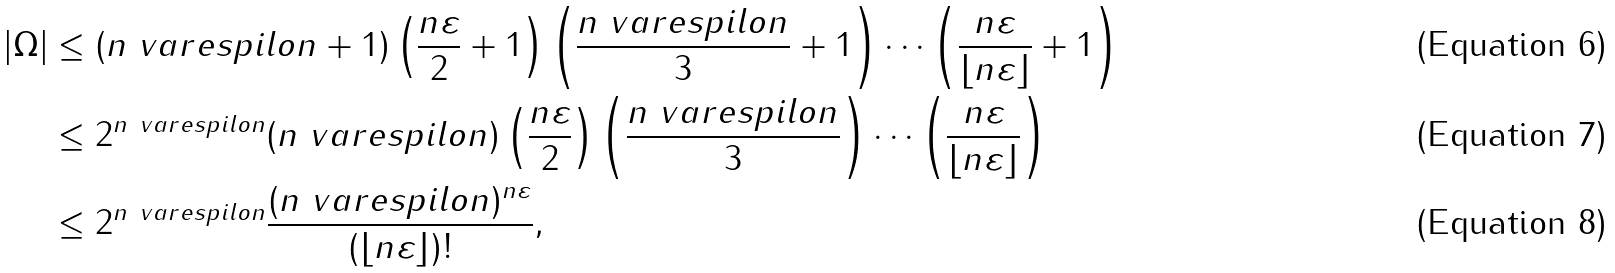<formula> <loc_0><loc_0><loc_500><loc_500>| \Omega | & \leq ( n \ v a r e s p i l o n + 1 ) \left ( \frac { n \varepsilon } { 2 } + 1 \right ) \left ( \frac { n \ v a r e s p i l o n } { 3 } + 1 \right ) \cdots \left ( \frac { n \varepsilon } { \lfloor { n \varepsilon \rfloor } } + 1 \right ) \\ & \leq 2 ^ { n \ v a r e s p i l o n } ( n \ v a r e s p i l o n ) \left ( \frac { n \varepsilon } { 2 } \right ) \left ( \frac { n \ v a r e s p i l o n } { 3 } \right ) \cdots \left ( \frac { n \varepsilon } { \lfloor { n \varepsilon \rfloor } } \right ) \\ & \leq 2 ^ { n \ v a r e s p i l o n } \frac { ( n \ v a r e s p i l o n ) ^ { n \varepsilon } } { ( \lfloor { n \varepsilon \rfloor } ) ! } ,</formula> 